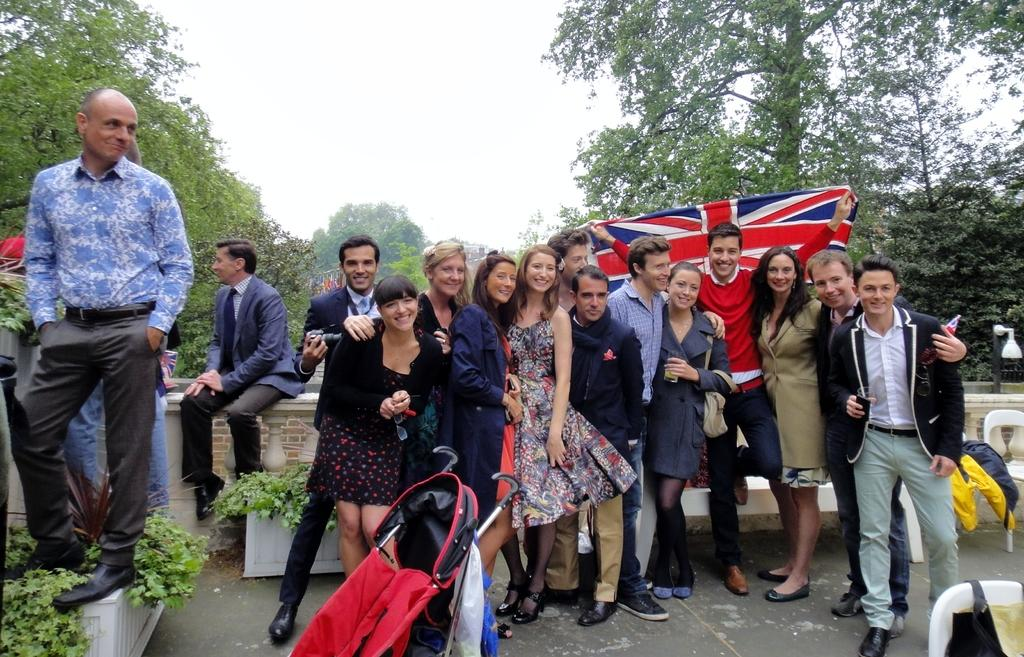Where was the image taken? The image was clicked outside. What can be seen in the middle of the image? There are trees in the middle of the image. What is visible at the top of the image? There is sky visible at the top of the image. How many persons are present in the image? There are multiple persons standing in the middle of the image. What is one of the persons holding? One of the persons is holding a flag. What type of brush is being used by the person in the image? There is no brush visible in the image. What kind of apparatus is being used by the person holding the flag? The person holding the flag is not using any apparatus in the image. 